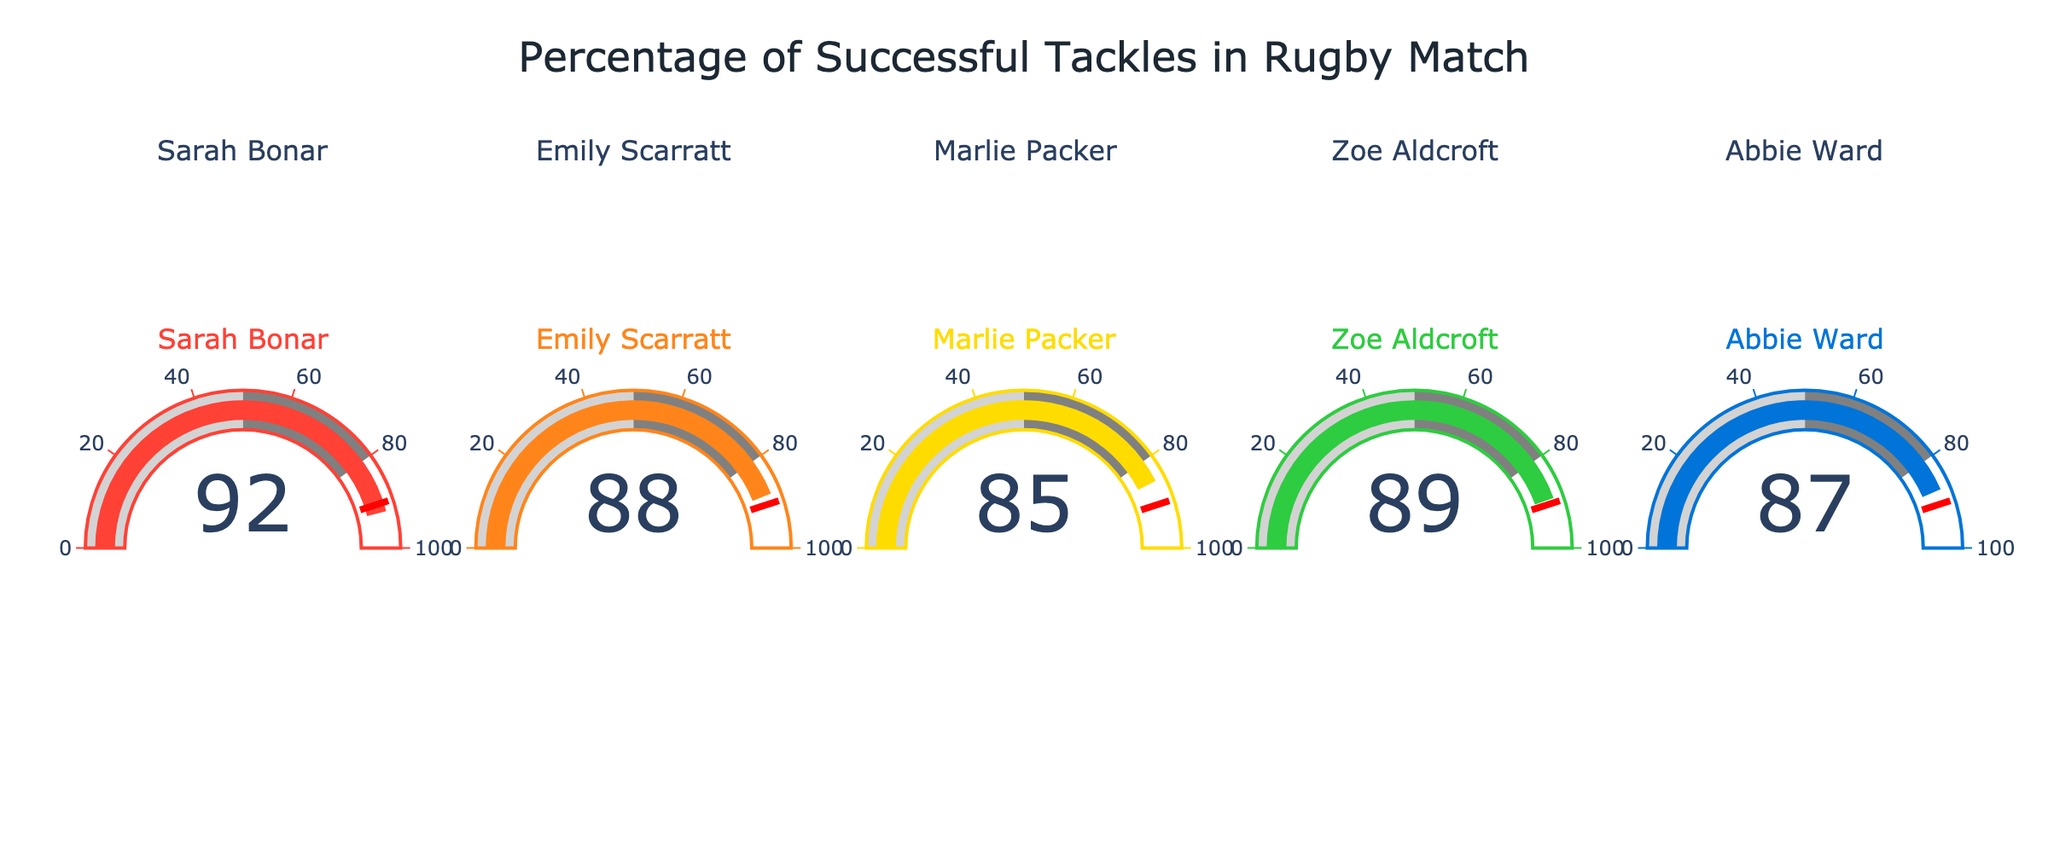What is the highest tackle success rate shown in the figure? Look at all the gauges displayed and identify the one with the highest number.
Answer: 92% What is the title of the figure? Locate the text at the top center of the figure.
Answer: Percentage of Successful Tackles in Rugby Match Which player has the lowest successful tackle percentage? Compare the values displayed on each of the gauges and identify the smallest number.
Answer: Marlie Packer What is the average successful tackle percentage for all players? Add all the percentages together: 92 + 88 + 85 + 89 + 87 = 441. Then divide by the number of players (5). 441 / 5.
Answer: 88.2% How many players have a successful tackle percentage greater than 85? Count the gauges where the percentage is higher than 85.
Answer: 4 What is the tackle success percentage of Emily Scarratt? Find Emily Scarratt's gauge and note the number displayed on it.
Answer: 88% What is the difference in successful tackle percentage between Zoe Aldcroft and Abbie Ward? Subtract the smaller percentage from the larger percentage: 89 - 87.
Answer: 2% Do any players have a successful tackle percentage equal to the threshold value of 90? Compare each player's successful tackle percentage to the threshold value of 90.
Answer: No Who has a higher successful tackle percentage, Abbie Ward or Marlie Packer? Compare the values on the gauges of Abbie Ward and Marlie Packer.
Answer: Abbie Ward What is the range of successful tackle percentages in the figure? Subtract the smallest percentage (85) from the largest percentage (92).
Answer: 7 